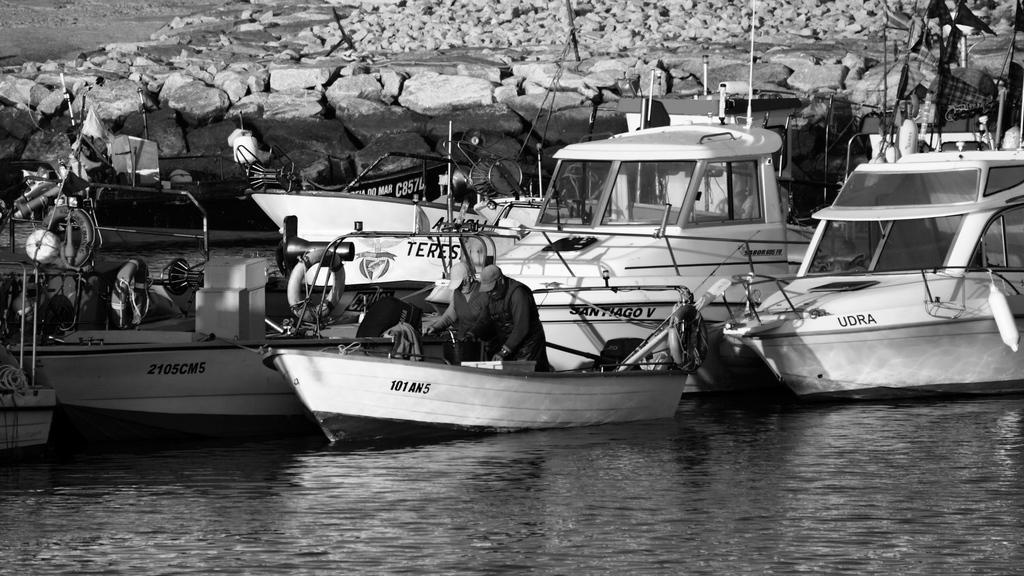<image>
Offer a succinct explanation of the picture presented. Two men are in a small fishing boat by other larger boats and one of them is named Udra. 